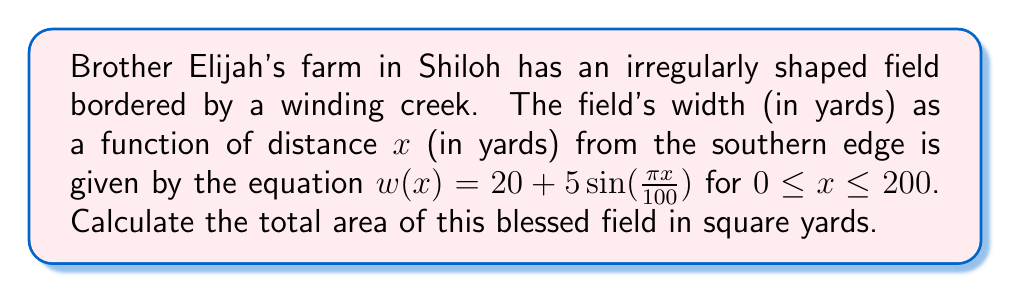Solve this math problem. To find the area of this irregularly shaped field, we need to use integration. The steps are as follows:

1) The area of the field can be calculated by integrating the width function over the length of the field:

   $$ A = \int_0^{200} w(x) dx $$

2) Substituting the given function for w(x):

   $$ A = \int_0^{200} (20 + 5\sin(\frac{\pi x}{100})) dx $$

3) We can split this into two integrals:

   $$ A = \int_0^{200} 20 dx + \int_0^{200} 5\sin(\frac{\pi x}{100}) dx $$

4) The first integral is straightforward:

   $$ \int_0^{200} 20 dx = 20x \bigg|_0^{200} = 4000 $$

5) For the second integral, we use the substitution method. Let $u = \frac{\pi x}{100}$, then $du = \frac{\pi}{100} dx$ or $dx = \frac{100}{\pi} du$:

   $$ \int_0^{200} 5\sin(\frac{\pi x}{100}) dx = 5 \cdot \frac{100}{\pi} \int_0^{2\pi} \sin(u) du $$

6) We know that $\int \sin(u) du = -\cos(u) + C$, so:

   $$ 5 \cdot \frac{100}{\pi} \int_0^{2\pi} \sin(u) du = 5 \cdot \frac{100}{\pi} [-\cos(u)]_0^{2\pi} = 5 \cdot \frac{100}{\pi} [(-\cos(2\pi) + \cos(0))] = 0 $$

7) Adding the results from steps 4 and 6:

   $$ A = 4000 + 0 = 4000 $$

Therefore, the total area of Brother Elijah's field is 4000 square yards.
Answer: 4000 square yards 